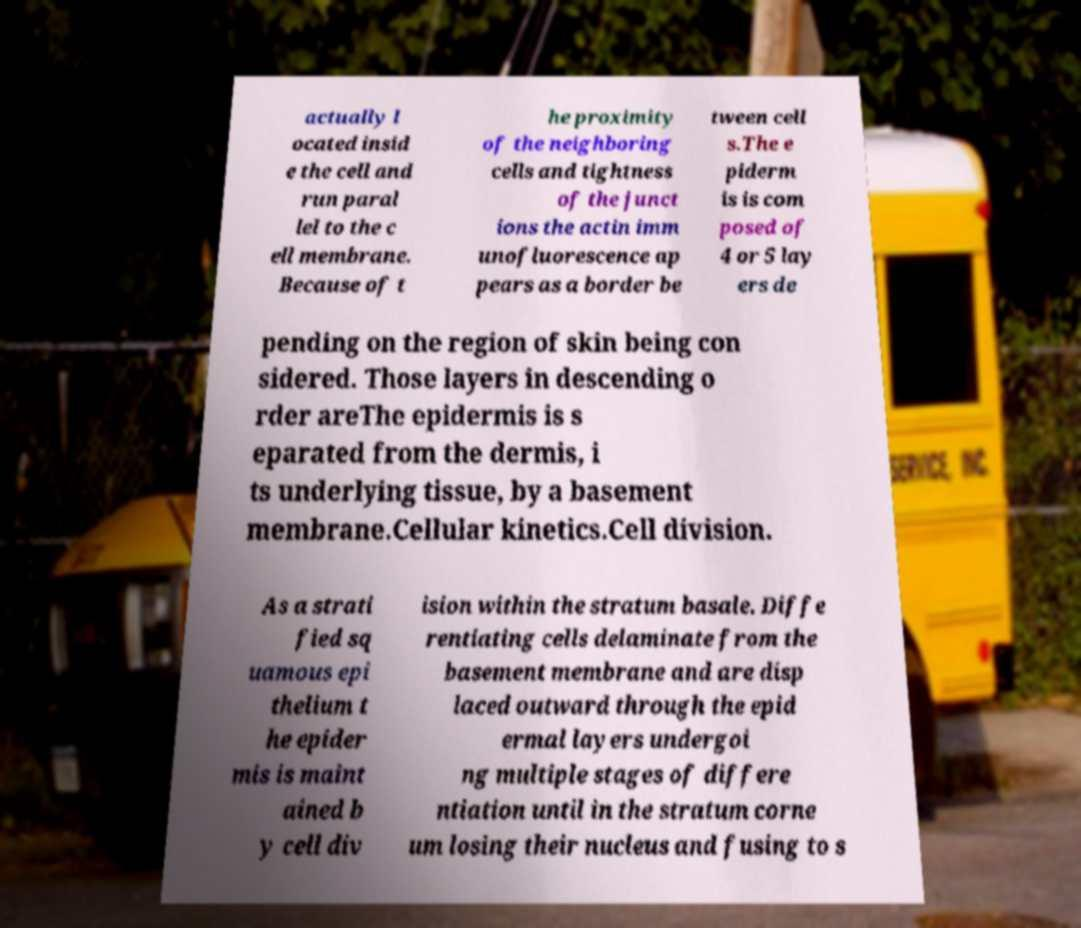Could you assist in decoding the text presented in this image and type it out clearly? actually l ocated insid e the cell and run paral lel to the c ell membrane. Because of t he proximity of the neighboring cells and tightness of the junct ions the actin imm unofluorescence ap pears as a border be tween cell s.The e piderm is is com posed of 4 or 5 lay ers de pending on the region of skin being con sidered. Those layers in descending o rder areThe epidermis is s eparated from the dermis, i ts underlying tissue, by a basement membrane.Cellular kinetics.Cell division. As a strati fied sq uamous epi thelium t he epider mis is maint ained b y cell div ision within the stratum basale. Diffe rentiating cells delaminate from the basement membrane and are disp laced outward through the epid ermal layers undergoi ng multiple stages of differe ntiation until in the stratum corne um losing their nucleus and fusing to s 